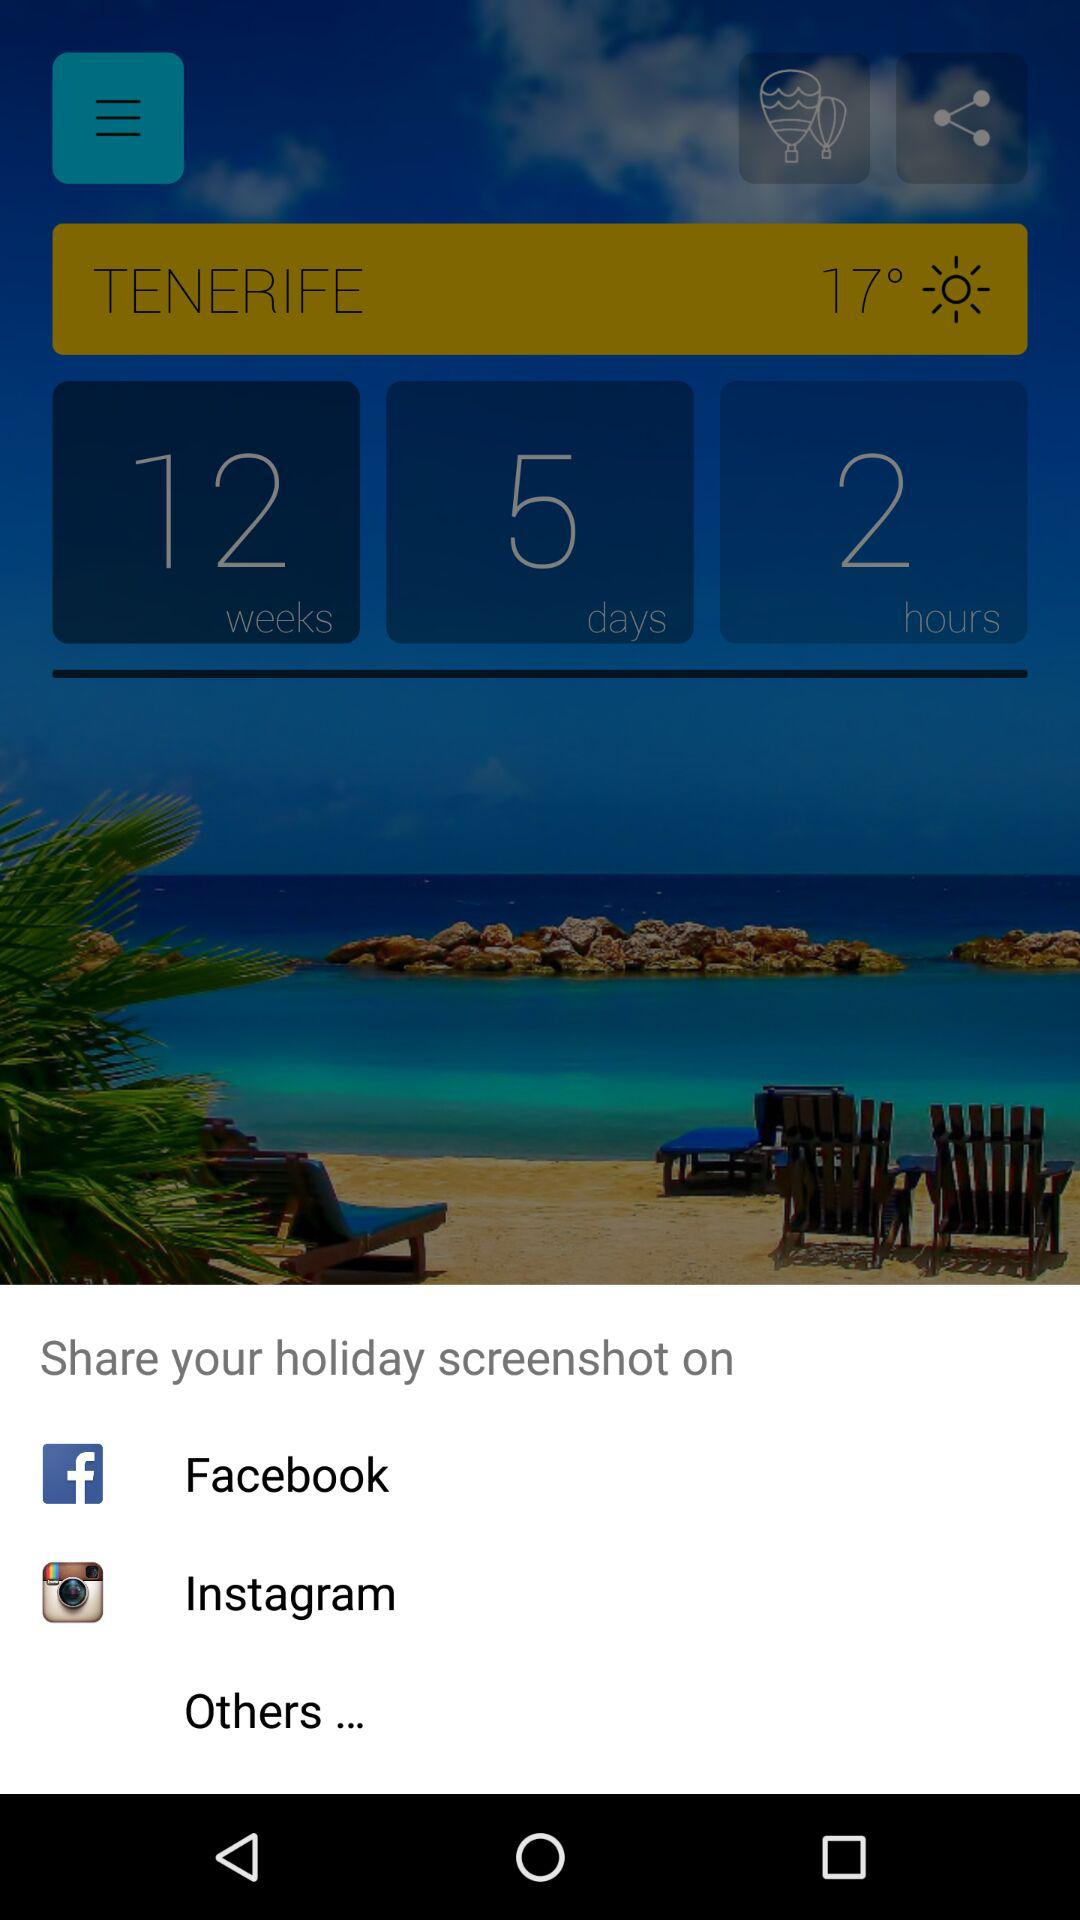What are the apps that can be used to share the holiday screenshot? The apps that can be used to share the holiday screenshot are "Facebook" and "Instagram". 